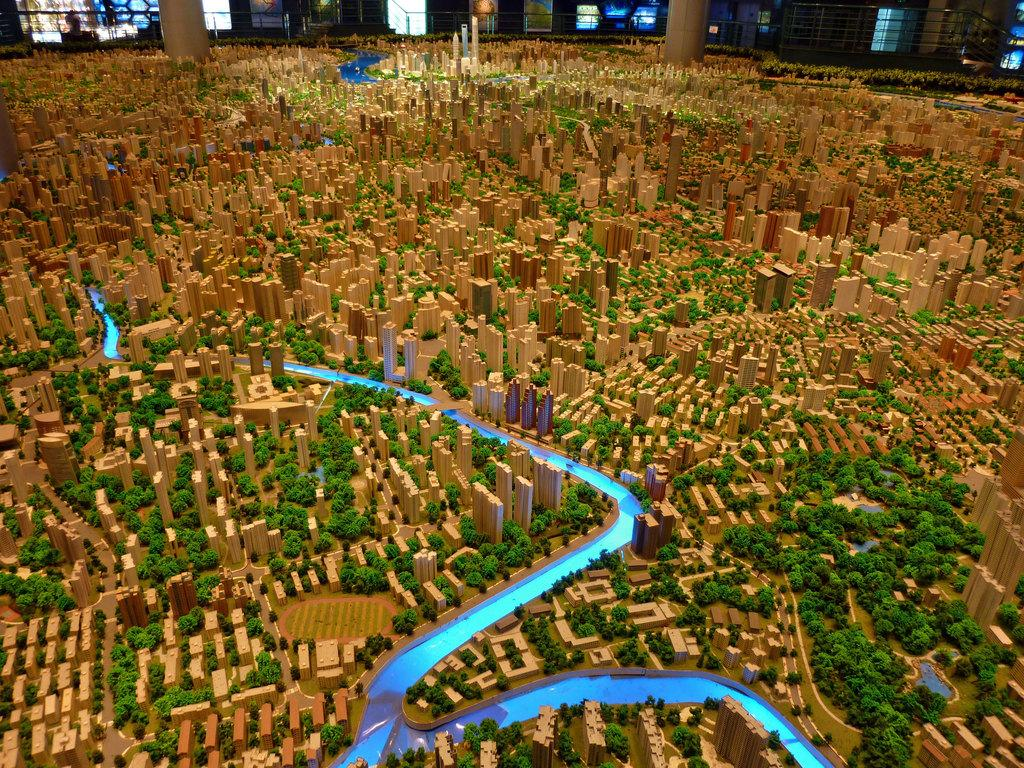What type of scene is depicted in the image? The image is of a miniature. What structures can be seen in the miniature? There are buildings and pillars at the back of the image. What natural elements are present in the miniature? There are trees and water visible in the image. Can you describe the person in the image? There is a person standing in the image. What feature can be seen in the image that might be used for support or safety? There is a railing in the image. What type of behavior is the stem exhibiting in the image? There is no stem present in the image; it is a miniature scene with buildings, trees, water, pillars, and a person. 